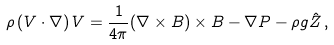<formula> <loc_0><loc_0><loc_500><loc_500>\rho \left ( { V } \cdot { \nabla } \right ) { V } = \frac { 1 } { 4 \pi } { \left ( { \nabla } \times { B } \right ) \times { B } } - { \nabla } P - \rho g { \hat { Z } } \, ,</formula> 